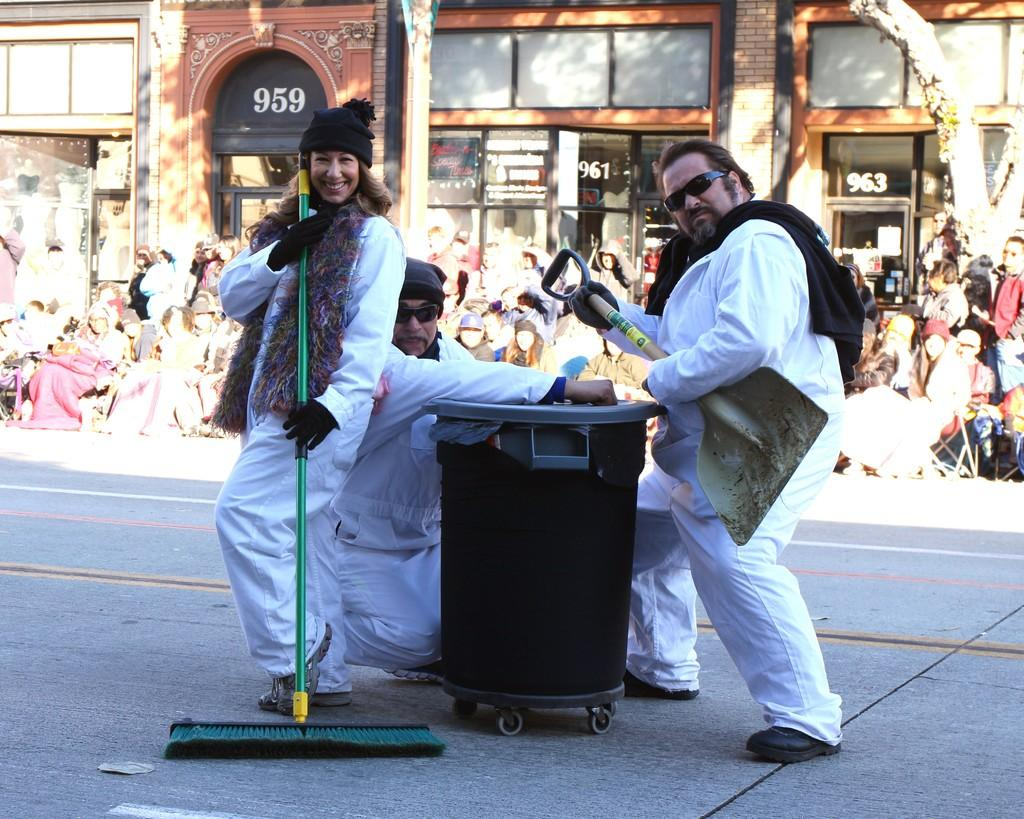<image>
Relay a brief, clear account of the picture shown. garbage cleaning people standing in the street in front of building 963 